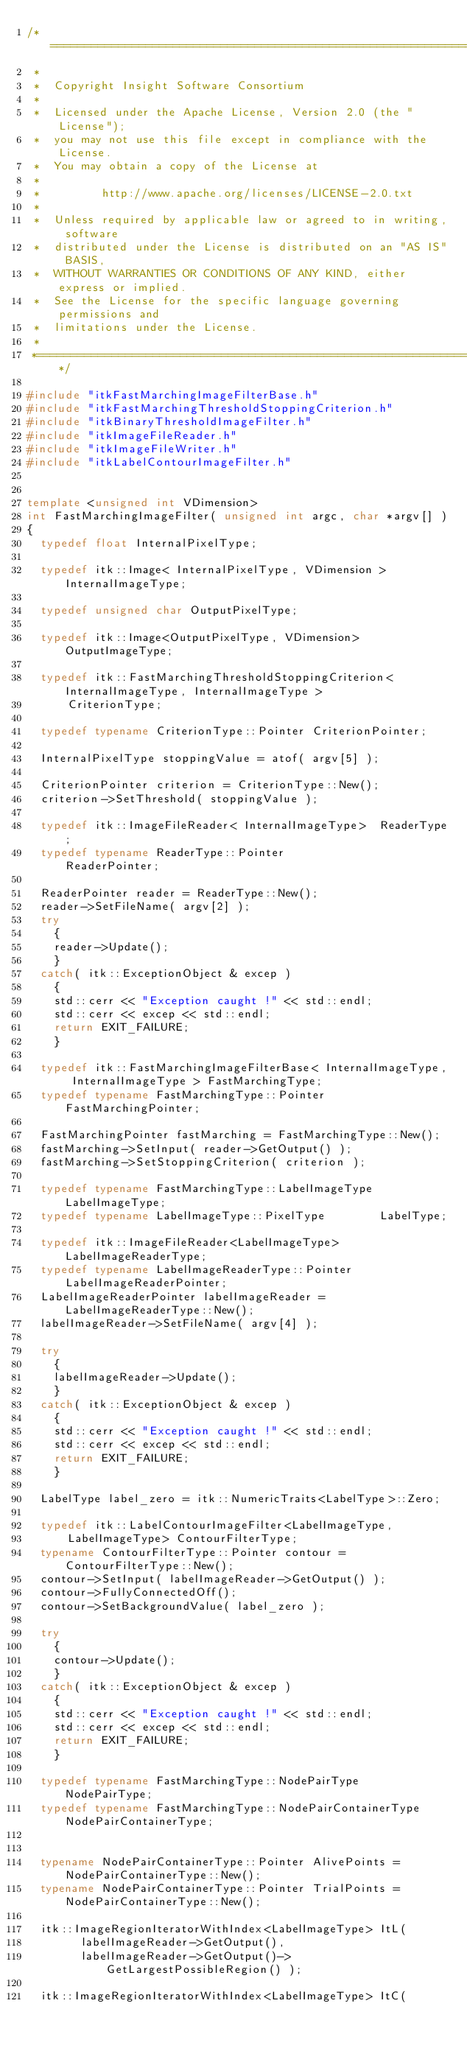Convert code to text. <code><loc_0><loc_0><loc_500><loc_500><_C++_>/*=========================================================================
 *
 *  Copyright Insight Software Consortium
 *
 *  Licensed under the Apache License, Version 2.0 (the "License");
 *  you may not use this file except in compliance with the License.
 *  You may obtain a copy of the License at
 *
 *         http://www.apache.org/licenses/LICENSE-2.0.txt
 *
 *  Unless required by applicable law or agreed to in writing, software
 *  distributed under the License is distributed on an "AS IS" BASIS,
 *  WITHOUT WARRANTIES OR CONDITIONS OF ANY KIND, either express or implied.
 *  See the License for the specific language governing permissions and
 *  limitations under the License.
 *
 *=========================================================================*/

#include "itkFastMarchingImageFilterBase.h"
#include "itkFastMarchingThresholdStoppingCriterion.h"
#include "itkBinaryThresholdImageFilter.h"
#include "itkImageFileReader.h"
#include "itkImageFileWriter.h"
#include "itkLabelContourImageFilter.h"


template <unsigned int VDimension>
int FastMarchingImageFilter( unsigned int argc, char *argv[] )
{
  typedef float InternalPixelType;

  typedef itk::Image< InternalPixelType, VDimension > InternalImageType;

  typedef unsigned char OutputPixelType;

  typedef itk::Image<OutputPixelType, VDimension> OutputImageType;

  typedef itk::FastMarchingThresholdStoppingCriterion< InternalImageType, InternalImageType >
      CriterionType;

  typedef typename CriterionType::Pointer CriterionPointer;

  InternalPixelType stoppingValue = atof( argv[5] );

  CriterionPointer criterion = CriterionType::New();
  criterion->SetThreshold( stoppingValue );

  typedef itk::ImageFileReader< InternalImageType>  ReaderType;
  typedef typename ReaderType::Pointer              ReaderPointer;

  ReaderPointer reader = ReaderType::New();
  reader->SetFileName( argv[2] );
  try
    {
    reader->Update();
    }
  catch( itk::ExceptionObject & excep )
    {
    std::cerr << "Exception caught !" << std::endl;
    std::cerr << excep << std::endl;
    return EXIT_FAILURE;
    }

  typedef itk::FastMarchingImageFilterBase< InternalImageType, InternalImageType > FastMarchingType;
  typedef typename FastMarchingType::Pointer FastMarchingPointer;

  FastMarchingPointer fastMarching = FastMarchingType::New();
  fastMarching->SetInput( reader->GetOutput() );
  fastMarching->SetStoppingCriterion( criterion );

  typedef typename FastMarchingType::LabelImageType LabelImageType;
  typedef typename LabelImageType::PixelType        LabelType;

  typedef itk::ImageFileReader<LabelImageType>    LabelImageReaderType;
  typedef typename LabelImageReaderType::Pointer  LabelImageReaderPointer;
  LabelImageReaderPointer labelImageReader = LabelImageReaderType::New();
  labelImageReader->SetFileName( argv[4] );

  try
    {
    labelImageReader->Update();
    }
  catch( itk::ExceptionObject & excep )
    {
    std::cerr << "Exception caught !" << std::endl;
    std::cerr << excep << std::endl;
    return EXIT_FAILURE;
    }

  LabelType label_zero = itk::NumericTraits<LabelType>::Zero;

  typedef itk::LabelContourImageFilter<LabelImageType,
      LabelImageType> ContourFilterType;
  typename ContourFilterType::Pointer contour = ContourFilterType::New();
  contour->SetInput( labelImageReader->GetOutput() );
  contour->FullyConnectedOff();
  contour->SetBackgroundValue( label_zero );

  try
    {
    contour->Update();
    }
  catch( itk::ExceptionObject & excep )
    {
    std::cerr << "Exception caught !" << std::endl;
    std::cerr << excep << std::endl;
    return EXIT_FAILURE;
    }

  typedef typename FastMarchingType::NodePairType           NodePairType;
  typedef typename FastMarchingType::NodePairContainerType  NodePairContainerType;


  typename NodePairContainerType::Pointer AlivePoints = NodePairContainerType::New();
  typename NodePairContainerType::Pointer TrialPoints = NodePairContainerType::New();

  itk::ImageRegionIteratorWithIndex<LabelImageType> ItL(
        labelImageReader->GetOutput(),
        labelImageReader->GetOutput()->GetLargestPossibleRegion() );

  itk::ImageRegionIteratorWithIndex<LabelImageType> ItC(</code> 